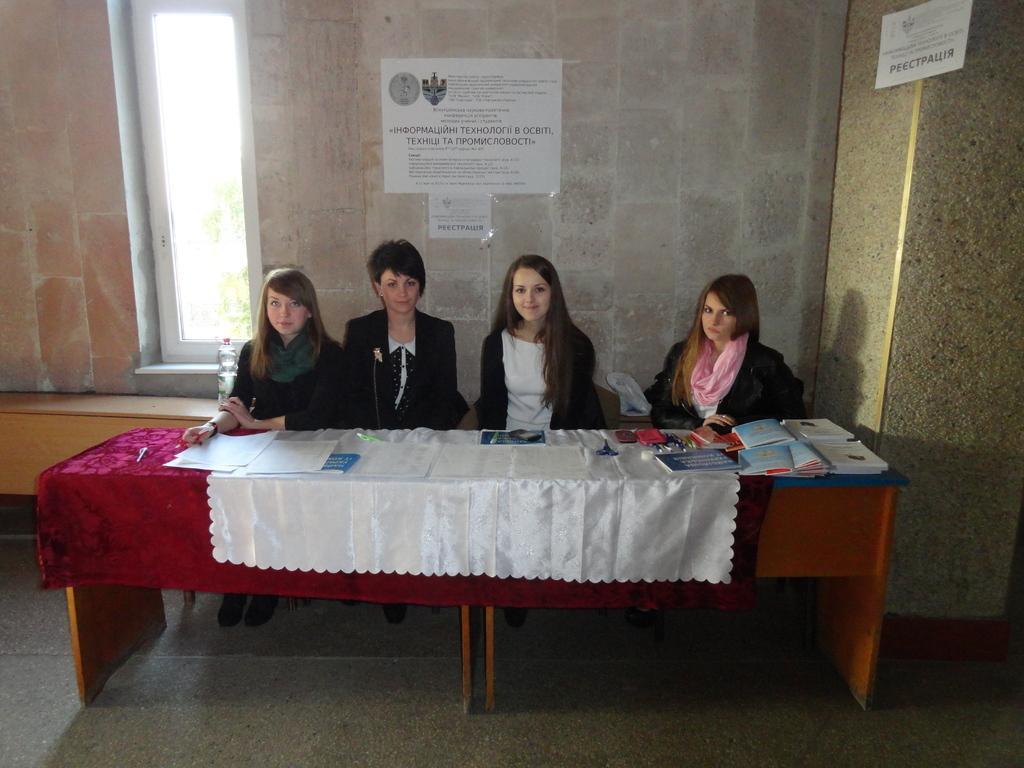Describe this image in one or two sentences. In this image there are four women who are sitting in front of them there is one table that table is covered with a red and white cloth. On that table there are some books, papers are there. On the top of the image there is one wall on that wall there is one paper sticked to the wall on the top of the right corner there is another paper on the left side of the image there is one window and on the left side there is one woman who is sitting beside her there is one bottle. 